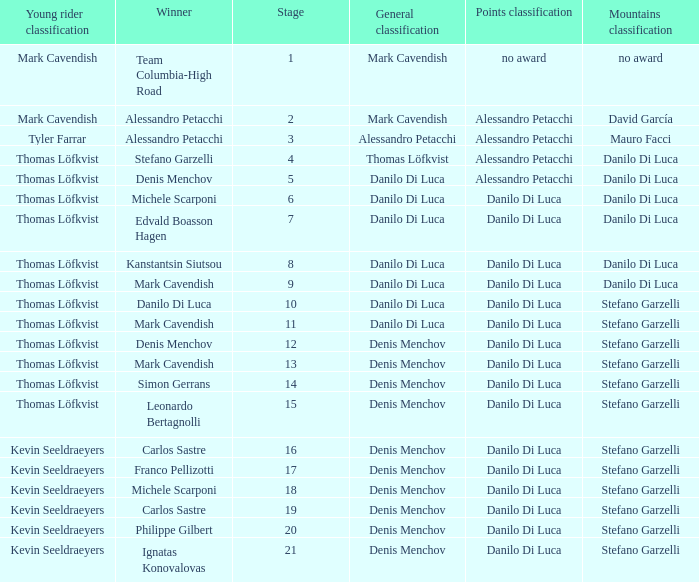When thomas löfkvist is the  young rider classification and alessandro petacchi is the points classification who are the general classifications?  Thomas Löfkvist, Danilo Di Luca. 